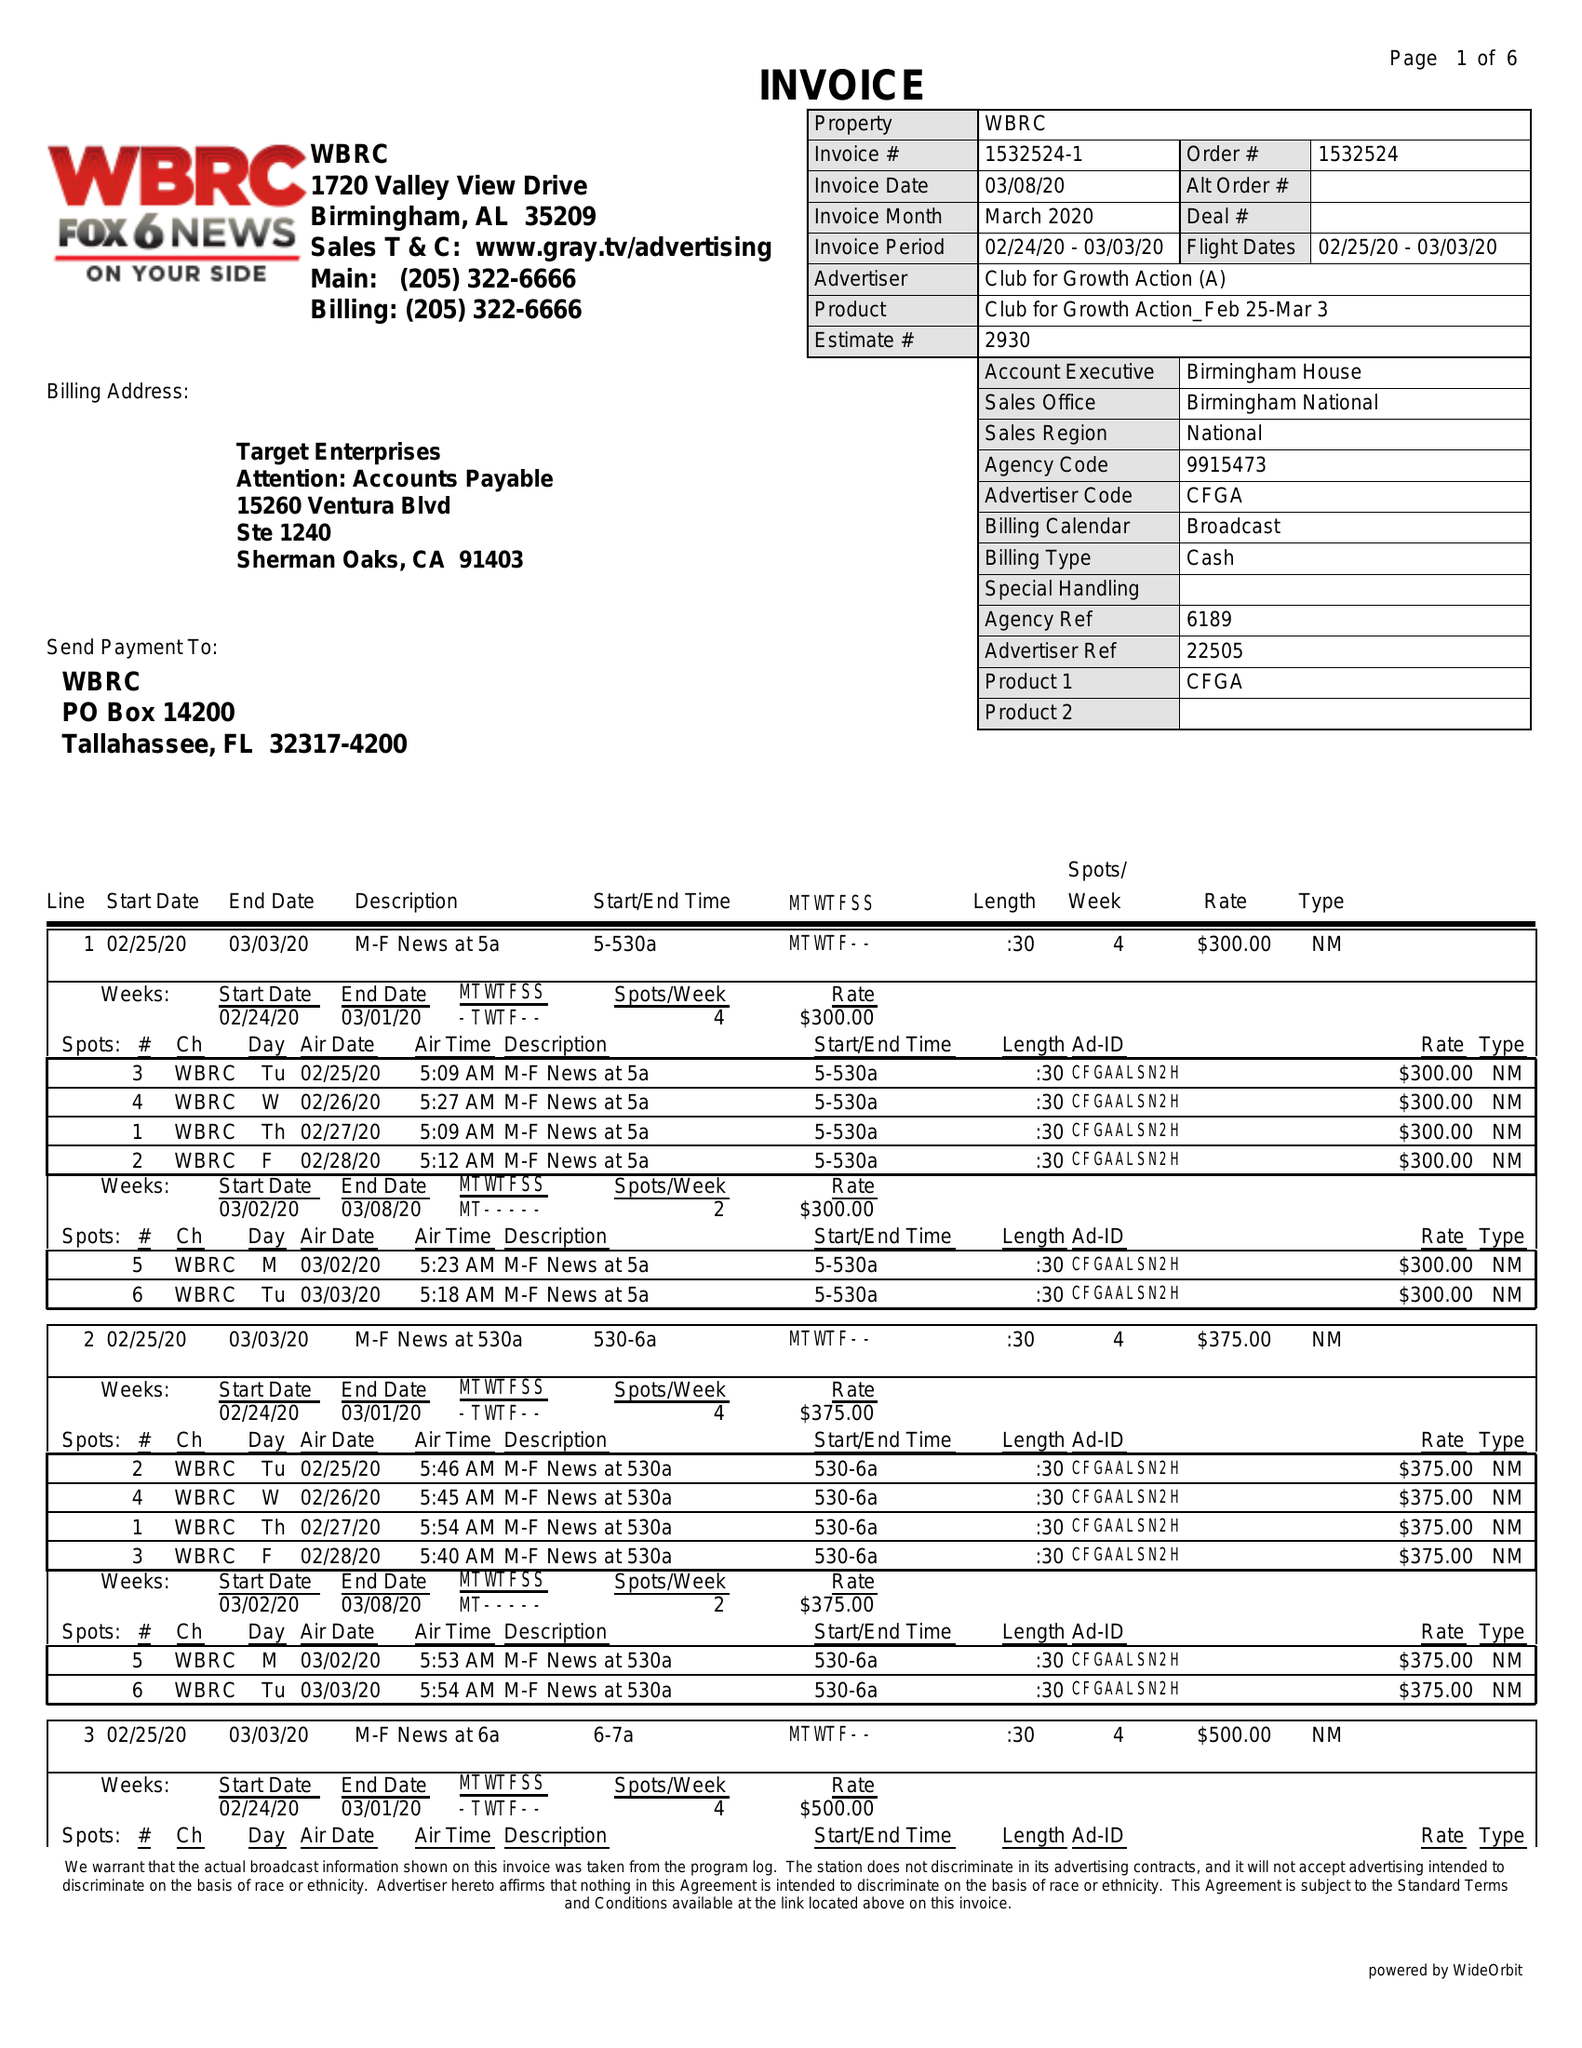What is the value for the gross_amount?
Answer the question using a single word or phrase. 36375.00 